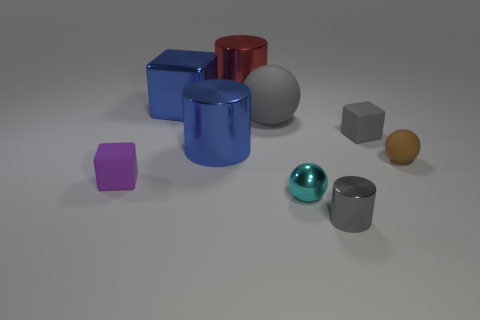Is the gray sphere made of the same material as the red cylinder?
Your answer should be compact. No. What number of things are either big objects or small shiny balls?
Your answer should be compact. 5. How many gray shiny cylinders have the same size as the cyan object?
Provide a succinct answer. 1. What shape is the tiny gray object in front of the cylinder on the left side of the large red metal cylinder?
Ensure brevity in your answer.  Cylinder. Are there fewer big gray balls than big cyan matte balls?
Offer a terse response. No. What color is the block on the right side of the metallic block?
Make the answer very short. Gray. What is the material of the tiny object that is both to the left of the small gray metallic cylinder and to the right of the big red cylinder?
Provide a short and direct response. Metal. What is the shape of the other big thing that is the same material as the brown object?
Give a very brief answer. Sphere. There is a large red cylinder that is on the left side of the large gray matte ball; how many large shiny objects are behind it?
Make the answer very short. 0. How many shiny things are both on the left side of the cyan thing and in front of the big gray thing?
Your answer should be compact. 1. 